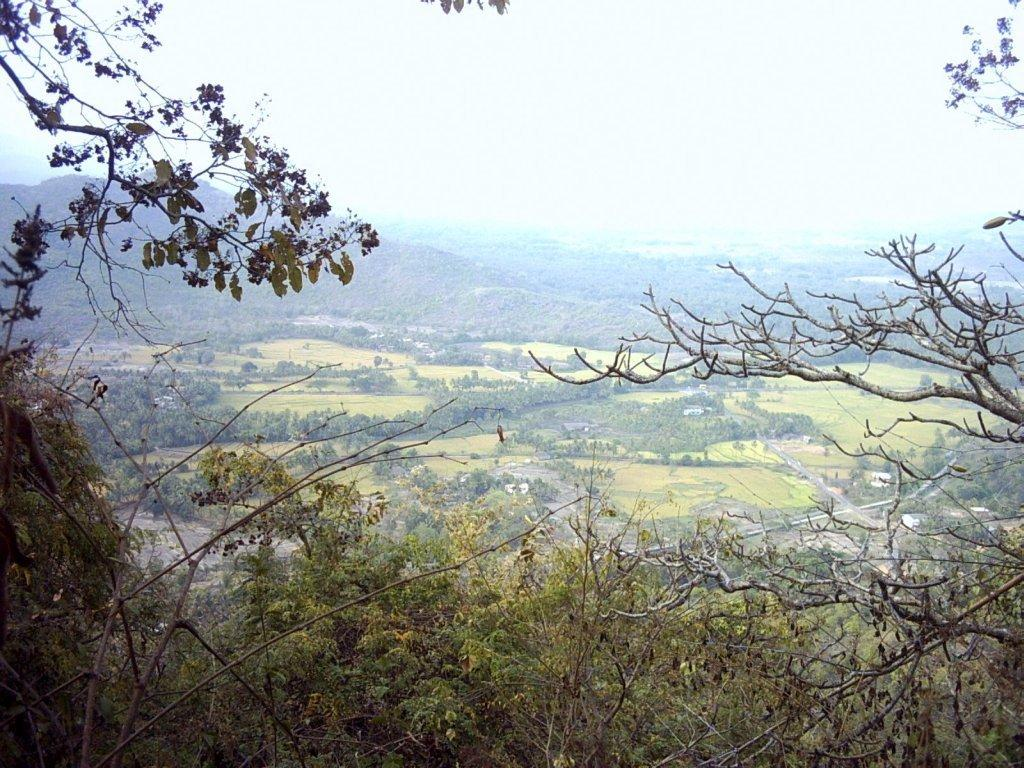What type of vegetation is in the foreground of the image? There are trees in the foreground of the image. What type of geographical feature can be seen in the background of the image? There are mountains in the background of the image. Are there any other trees visible in the image? Yes, there are additional trees in the background of the image. What is visible at the top of the image? The sky is visible at the top of the image. What year is mentioned in the caption of the image? There is no caption present in the image, so no year can be identified. Can you see a yak in the image? There is no yak present in the image. 